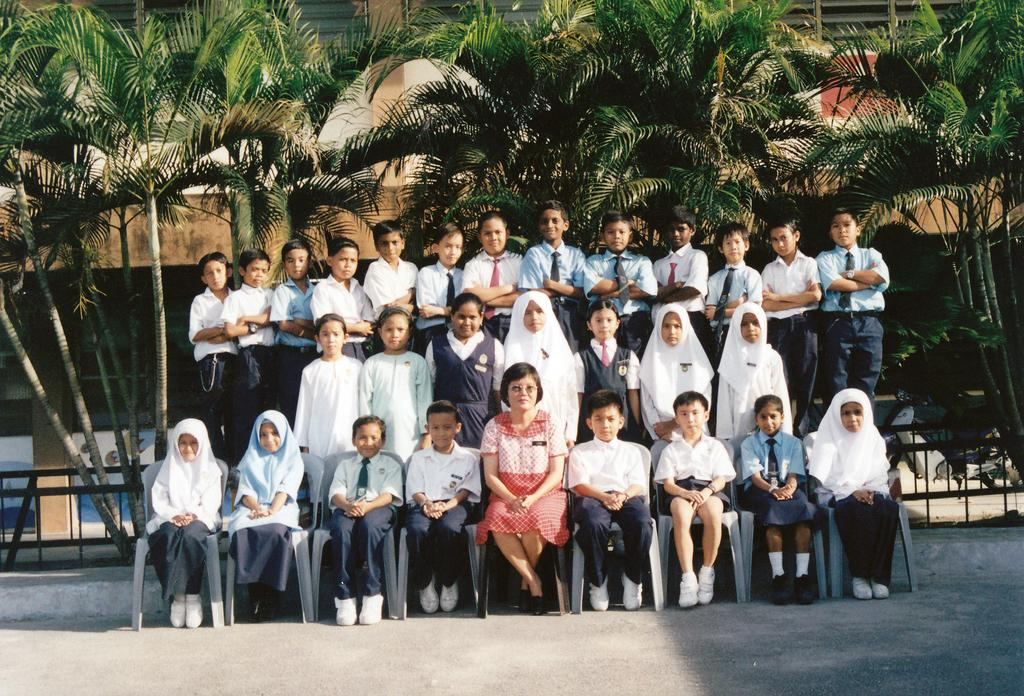How many people are in the image? There is a group of people in the image, but the exact number is not specified. What are some of the people in the image doing? Some people are sitting on chairs, while others are standing. What can be seen in the background of the image? Trees, metal rods, and a building are visible in the background. What color is the mom's shirt in the image? There is no mention of a mom or a shirt in the image, so we cannot answer this question. Is there a stick visible in the image? There is no stick present in the image. 